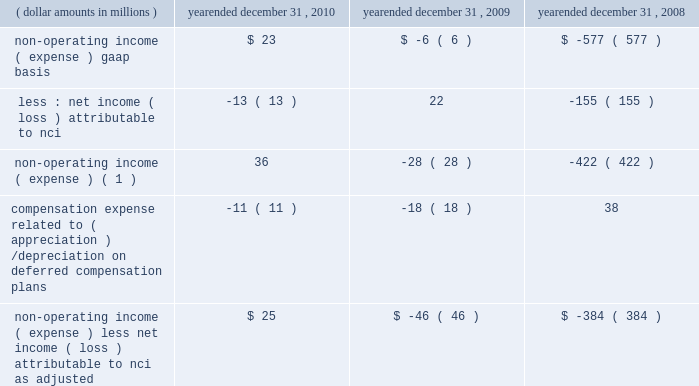4 4 m a n a g e m e n t 2019 s d i s c u s s i o n notes to table ( continued ) ( a ) ( continued ) management believes that operating income , as adjusted , and operating margin , as adjusted , are effective indicators of blackrock 2019s financial performance over time .
As such , management believes that operating income , as adjusted , and operating margin , as adjusted , provide useful disclosure to investors .
Operating income , as adjusted : bgi transaction and integration costs recorded in 2010 and 2009 consist principally of certain advisory payments , compensation expense , legal fees , marketing and promotional , occupancy and consulting expenses incurred in conjunction with the bgi transaction .
Restructuring charges recorded in 2009 and 2008 consist of compensation costs , occupancy costs and professional fees .
The expenses associated with restructuring and bgi transaction and integration costs have been deemed non-recurring by management and have been excluded from operating income , as adjusted , to help enhance the comparability of this information to the current reporting periods .
As such , management believes that operating margins exclusive of these costs are useful measures in evaluating blackrock 2019s operating performance for the respective periods .
The portion of compensation expense associated with certain long-term incentive plans ( 201cltip 201d ) that will be funded through the distribution to participants of shares of blackrock stock held by pnc and a merrill lynch cash compensation contribution , a portion of which has been received , have been excluded because these charges ultimately do not impact blackrock 2019s book value .
Compensation expense associated with appreciation/ ( depreciation ) on investments related to certain blackrock deferred compensation plans has been excluded as returns on investments set aside for these plans , which substantially offset this expense , are reported in non-operating income ( expense ) .
Operating margin , as adjusted : operating income used for measuring operating margin , as adjusted , is equal to operating income , as adjusted , excluding the impact of closed-end fund launch costs and commissions .
Management believes that excluding such costs and commissions is useful because these costs can fluctuate considerably and revenues associated with the expenditure of these costs will not fully impact the company 2019s results until future periods .
Operating margin , as adjusted , allows the company to compare performance from period-to-period by adjusting for items that may not recur , recur infrequently or may fluctuate based on market movements , such as restructuring charges , transaction and integration costs , closed-end fund launch costs , commissions paid to certain employees as compensation and fluctua- tions in compensation expense based on mark-to-market movements in investments held to fund certain compensation plans .
The company also uses operating margin , as adjusted , to monitor corporate performance and efficiency and as a benchmark to compare its performance to other companies .
Management uses both the gaap and non-gaap financial measures in evaluating the financial performance of blackrock .
The non-gaap measure by itself may pose limitations because it does not include all of the company 2019s revenues and expenses .
Revenue used for operating margin , as adjusted , excludes distribution and servicing costs paid to related parties and other third parties .
Management believes that excluding such costs is useful to blackrock because it creates consistency in the treatment for certain contracts for similar services , which due to the terms of the contracts , are accounted for under gaap on a net basis within investment advisory , administration fees and securities lending revenue .
Amortization of deferred sales commissions is excluded from revenue used for operating margin measurement , as adjusted , because such costs , over time , offset distribution fee revenue earned by the company .
Reimbursable property management compensation represented com- pensation and benefits paid to personnel of metric property management , inc .
( 201cmetric 201d ) , a subsidiary of blackrock realty advisors , inc .
( 201crealty 201d ) .
Prior to the transfer in 2008 , these employees were retained on metric 2019s payroll when certain properties were acquired by realty 2019s clients .
The related compensation and benefits were fully reimbursed by realty 2019s clients and have been excluded from revenue used for operating margin , as adjusted , because they did not bear an economic cost to blackrock .
For each of these items , blackrock excludes from revenue used for operating margin , as adjusted , the costs related to each of these items as a proxy for such offsetting revenues .
( b ) non-operating income ( expense ) , less net income ( loss ) attributable to non-controlling interests , as adjusted : non-operating income ( expense ) , less net income ( loss ) attributable to non-controlling interests ( 201cnci 201d ) , as adjusted , equals non-operating income ( expense ) , gaap basis , less net income ( loss ) attributable to nci , gaap basis , adjusted for compensation expense associated with depreciation/ ( appreciation ) on investments related to certain blackrock deferred compensation plans .
The compensation expense offset is recorded in operating income .
This compensation expense has been included in non-operating income ( expense ) , less net income ( loss ) attributable to nci , as adjusted , to offset returns on investments set aside for these plans , which are reported in non-operating income ( expense ) , gaap basis. .
Non-operating income ( expense ) ( 1 ) 36 ( 28 ) ( 422 ) compensation expense related to ( appreciation ) / depreciation on deferred compensation plans ( 11 ) ( 18 ) 38 non-operating income ( expense ) , less net income ( loss ) attributable to nci , as adjusted $ 25 ( $ 46 ) ( $ 384 ) ( 1 ) net of net income ( loss ) attributable to non-controlling interests .
Management believes that non-operating income ( expense ) , less net income ( loss ) attributable to nci , as adjusted , provides for comparability of this information to prior periods and is an effective measure for reviewing blackrock 2019s non-operating contribution to its results .
As compensation expense associated with ( appreciation ) /depreciation on investments related to certain deferred compensation plans , which is included in operating income , offsets the gain/ ( loss ) on the investments set aside for these plans , management believes that non-operating income ( expense ) , less net income ( loss ) attributable to nci , as adjusted , provides a useful measure , for both management and investors , of blackrock 2019s non-operating results that impact book value. .
What is the percent change in non-operating income ( expense ) gaap basis from 2009 to 2010? 
Computations: ((23 + 6) / 6)
Answer: 4.83333. 